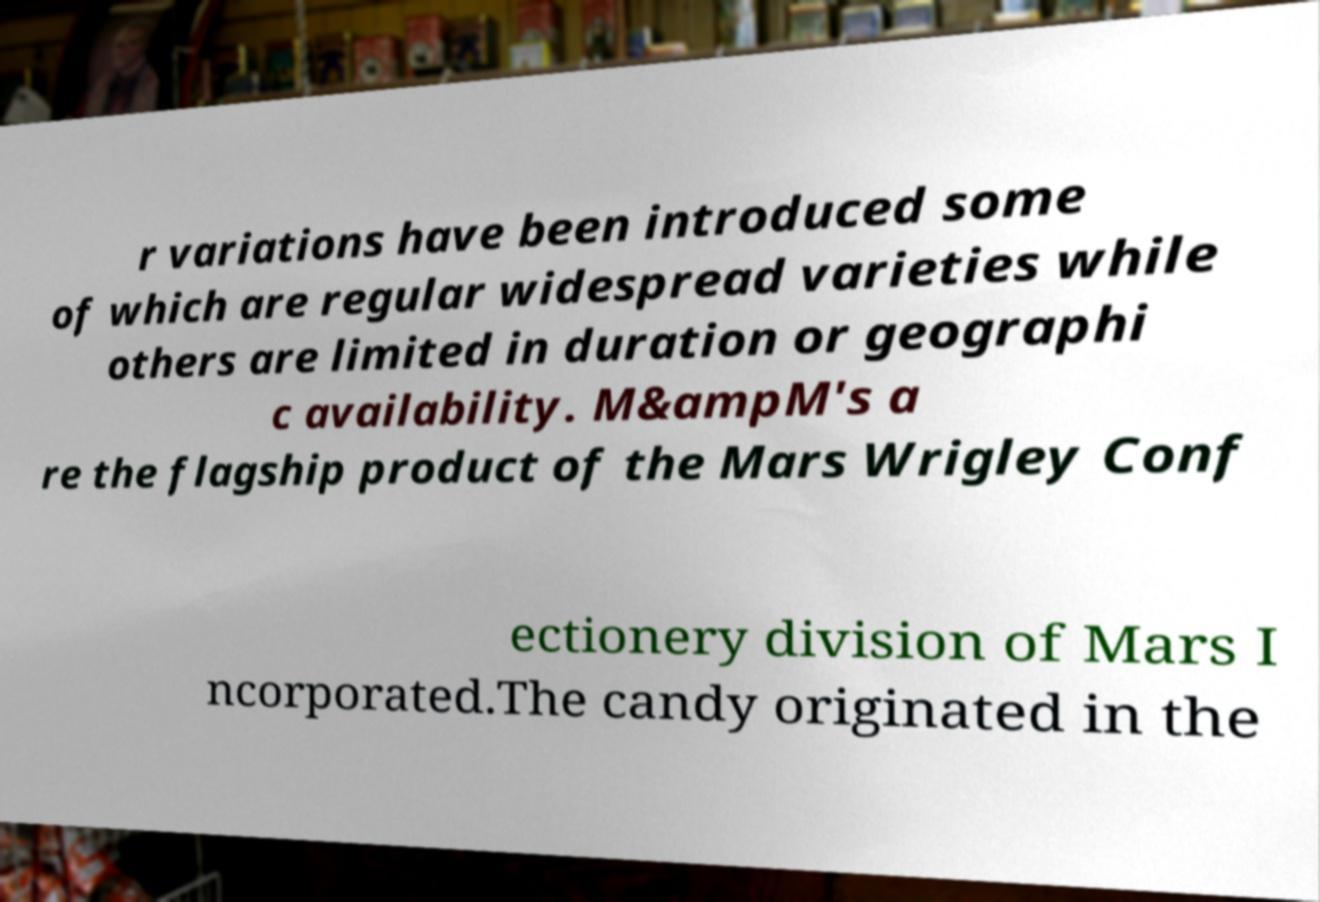There's text embedded in this image that I need extracted. Can you transcribe it verbatim? r variations have been introduced some of which are regular widespread varieties while others are limited in duration or geographi c availability. M&ampM's a re the flagship product of the Mars Wrigley Conf ectionery division of Mars I ncorporated.The candy originated in the 